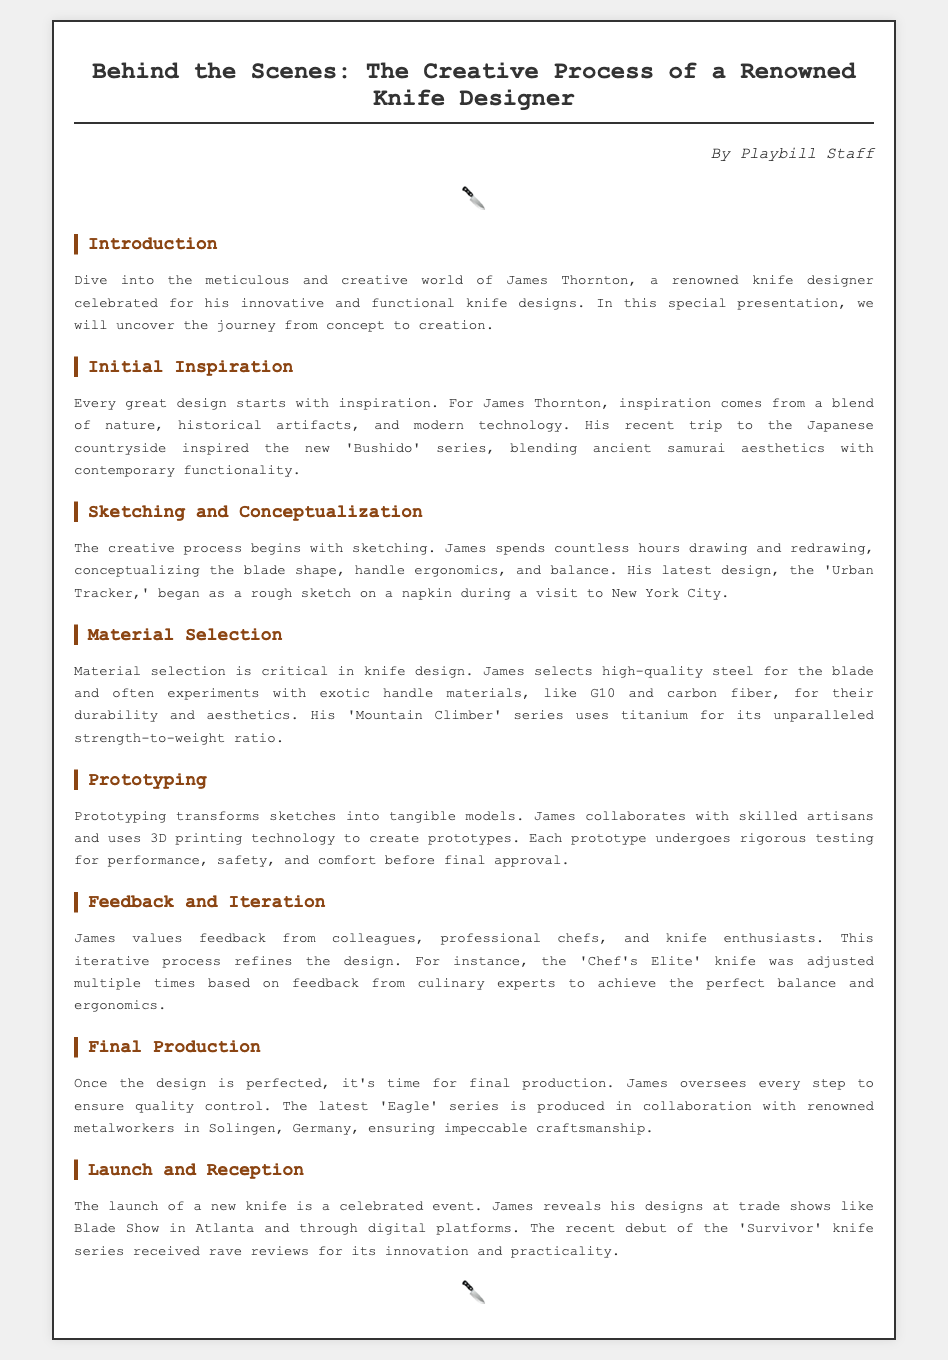What is the name of the knife designer? The document introduces James Thornton as the renowned knife designer.
Answer: James Thornton What series was inspired by the Japanese countryside? The 'Bushido' series is mentioned as being inspired by a recent trip to the Japanese countryside.
Answer: Bushido What is the primary focus during the sketching and conceptualization phase? The document states that the focus is on the blade shape, handle ergonomics, and balance.
Answer: Blade shape, handle ergonomics, and balance What material is used in the 'Mountain Climber' series? The document indicates that titanium is used for its strength-to-weight ratio in the 'Mountain Climber' series.
Answer: Titanium Where does James reveal his designs? The document mentions reveals at trade shows like Blade Show in Atlanta and through digital platforms.
Answer: Blade Show in Atlanta What is the main technology used in prototyping? The document cites 3D printing technology as a key tool in creating prototypes.
Answer: 3D printing technology Which knife received feedback from culinary experts? The 'Chef's Elite' knife is noted for adjustments made based on culinary expert feedback.
Answer: Chef's Elite What is the focus of the feedback and iteration process? The process aims to refine the design based on insights from colleagues and knife enthusiasts.
Answer: Refine the design Who collaborates on the final production of the latest series? The document states that James collaborates with renowned metalworkers in Solingen, Germany.
Answer: Renowned metalworkers in Solingen, Germany 